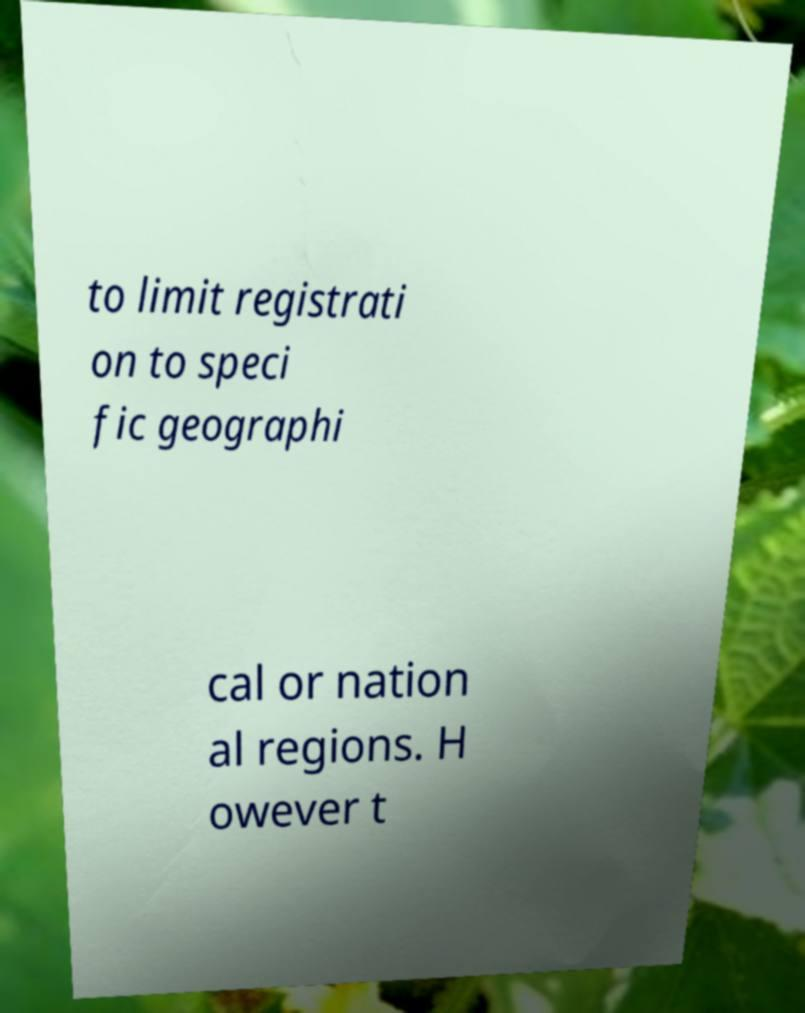Can you read and provide the text displayed in the image?This photo seems to have some interesting text. Can you extract and type it out for me? to limit registrati on to speci fic geographi cal or nation al regions. H owever t 